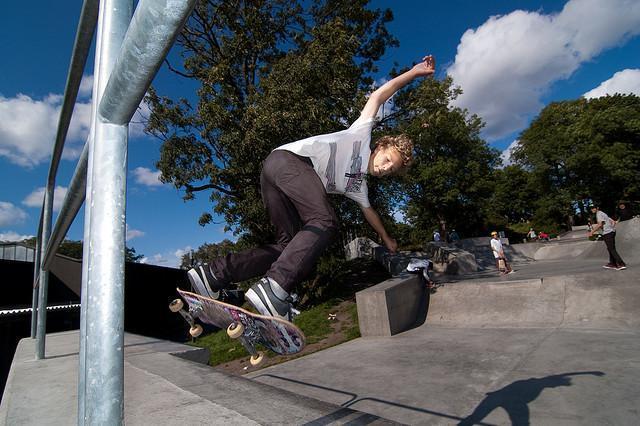What will happen to the boy next?
Choose the right answer and clarify with the format: 'Answer: answer
Rationale: rationale.'
Options: Falling off, lying down, landing, flipping. Answer: landing.
Rationale: The boy is going back to the ground to land. 